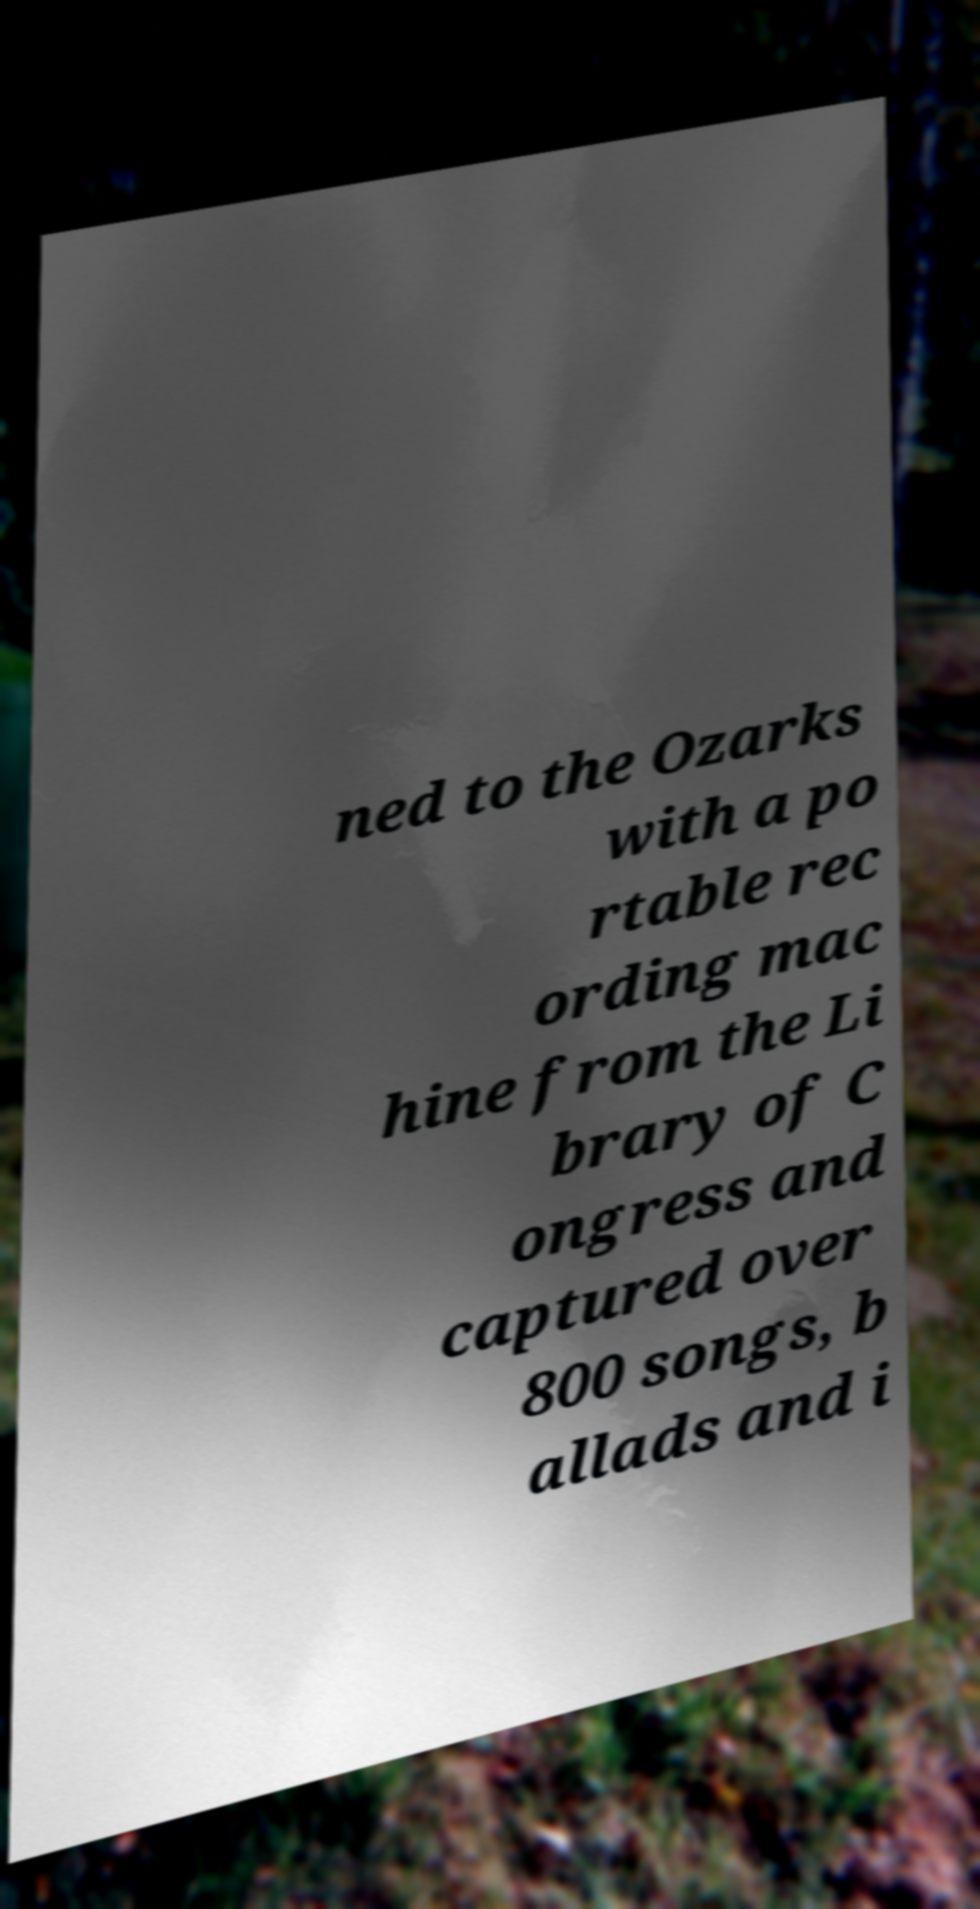Can you read and provide the text displayed in the image?This photo seems to have some interesting text. Can you extract and type it out for me? ned to the Ozarks with a po rtable rec ording mac hine from the Li brary of C ongress and captured over 800 songs, b allads and i 